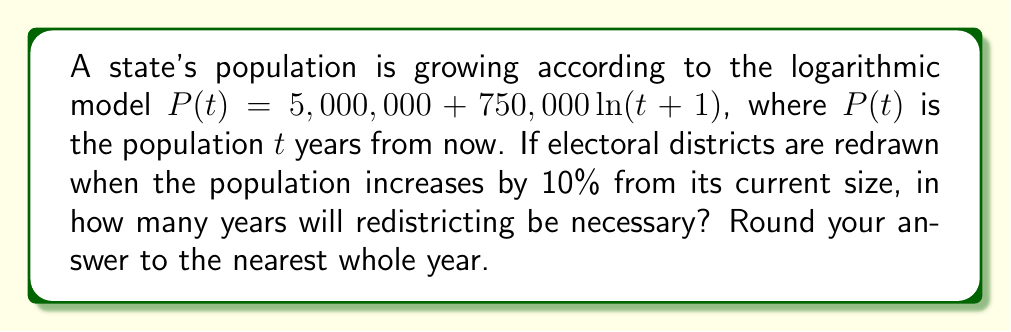What is the answer to this math problem? 1) First, we need to find the current population by setting $t=0$:
   $P(0) = 5,000,000 + 750,000 \ln(0+1) = 5,000,000$

2) The population that triggers redistricting is 10% more than the current population:
   $5,000,000 \times 1.10 = 5,500,000$

3) Now, we need to solve the equation:
   $5,500,000 = 5,000,000 + 750,000 \ln(t+1)$

4) Subtract 5,000,000 from both sides:
   $500,000 = 750,000 \ln(t+1)$

5) Divide both sides by 750,000:
   $\frac{2}{3} = \ln(t+1)$

6) Apply $e^x$ to both sides:
   $e^{\frac{2}{3}} = t+1$

7) Subtract 1 from both sides:
   $e^{\frac{2}{3}} - 1 = t$

8) Calculate the value:
   $t \approx 0.9477 \approx 1.95$ years

9) Rounding to the nearest whole year:
   $t = 2$ years
Answer: 2 years 